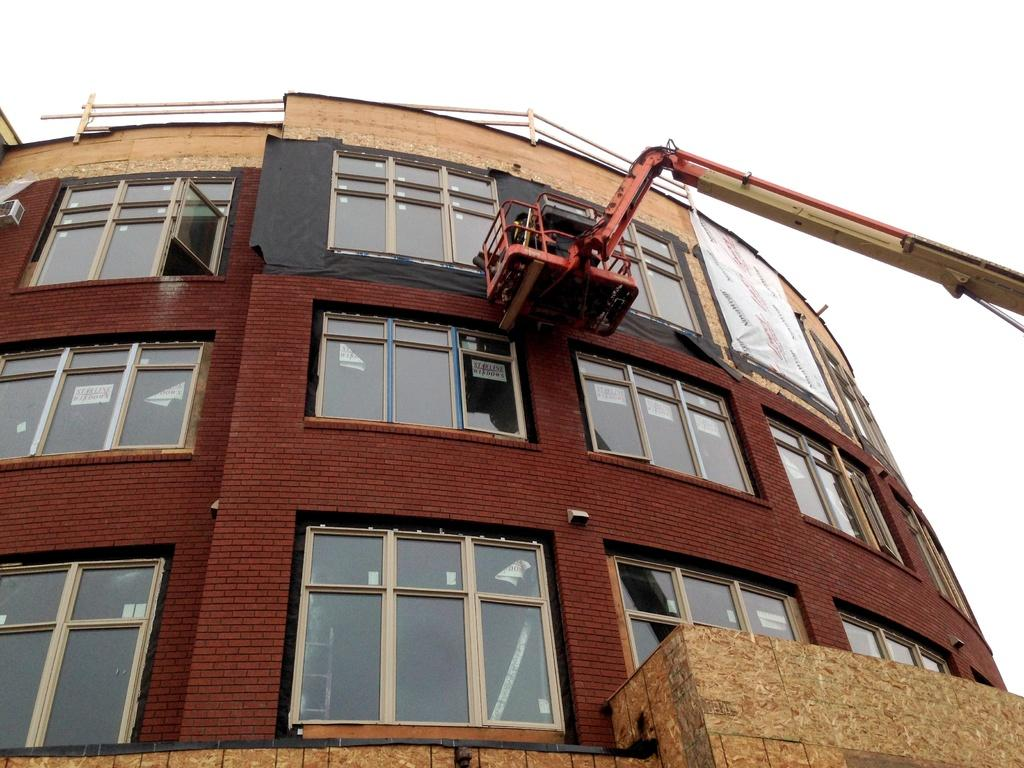What type of building is shown in the image? The image shows a building with glass windows. What feature can be seen at the top of the building? The building has a fence at the top. What is located on the right side of the image? There is a crane on the right side of the image. What is visible at the top of the image? The sky is visible at the top of the image. How many visitors can be seen in the image with fangs? There are no visitors or fangs present in the image. What type of transport is used to move the building in the image? The image does not show the building moving, and there is no transport visible. 